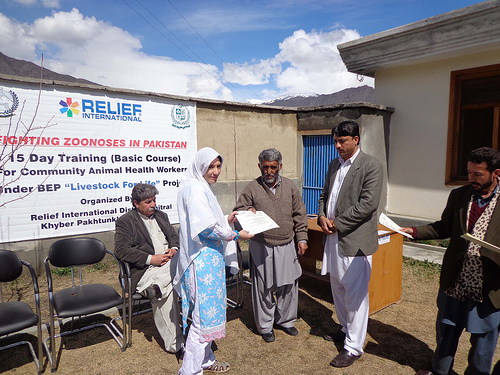<image>
Can you confirm if the chair is to the right of the man? Yes. From this viewpoint, the chair is positioned to the right side relative to the man. 